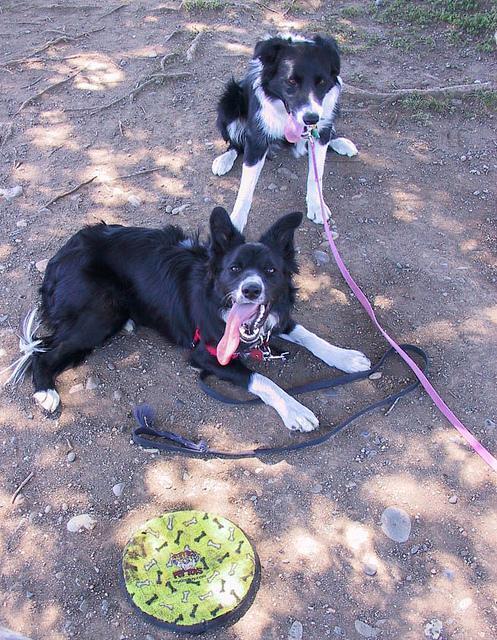How many dogs are there?
Give a very brief answer. 2. 